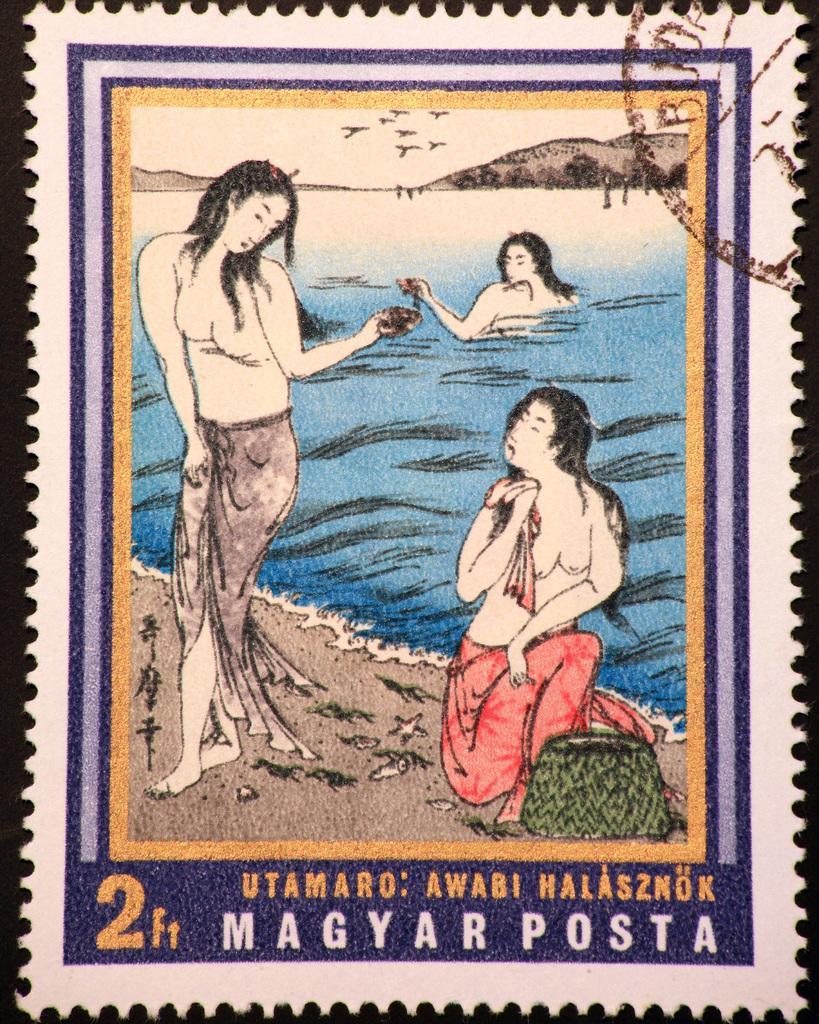Could you give a brief overview of what you see in this image? This is a postage stamp. 2 women are present. Behind them a woman is present in the water. At the back there are mountains and birds are flying in the sky. 